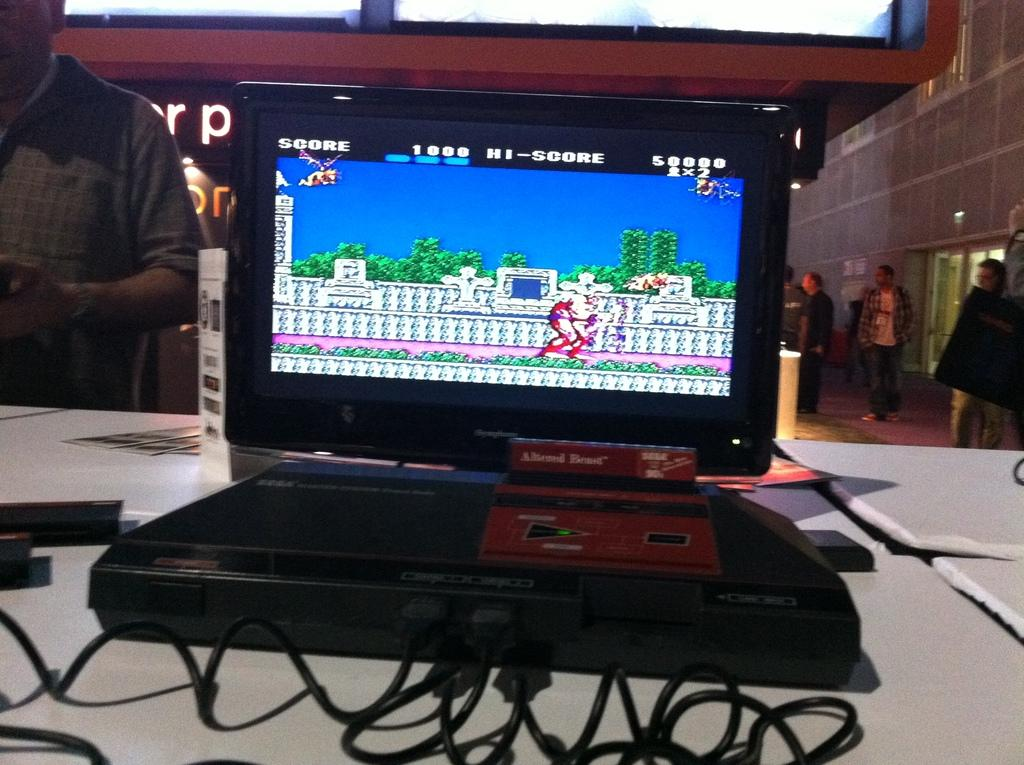<image>
Render a clear and concise summary of the photo. A console game displays the current score and high score at the top. 